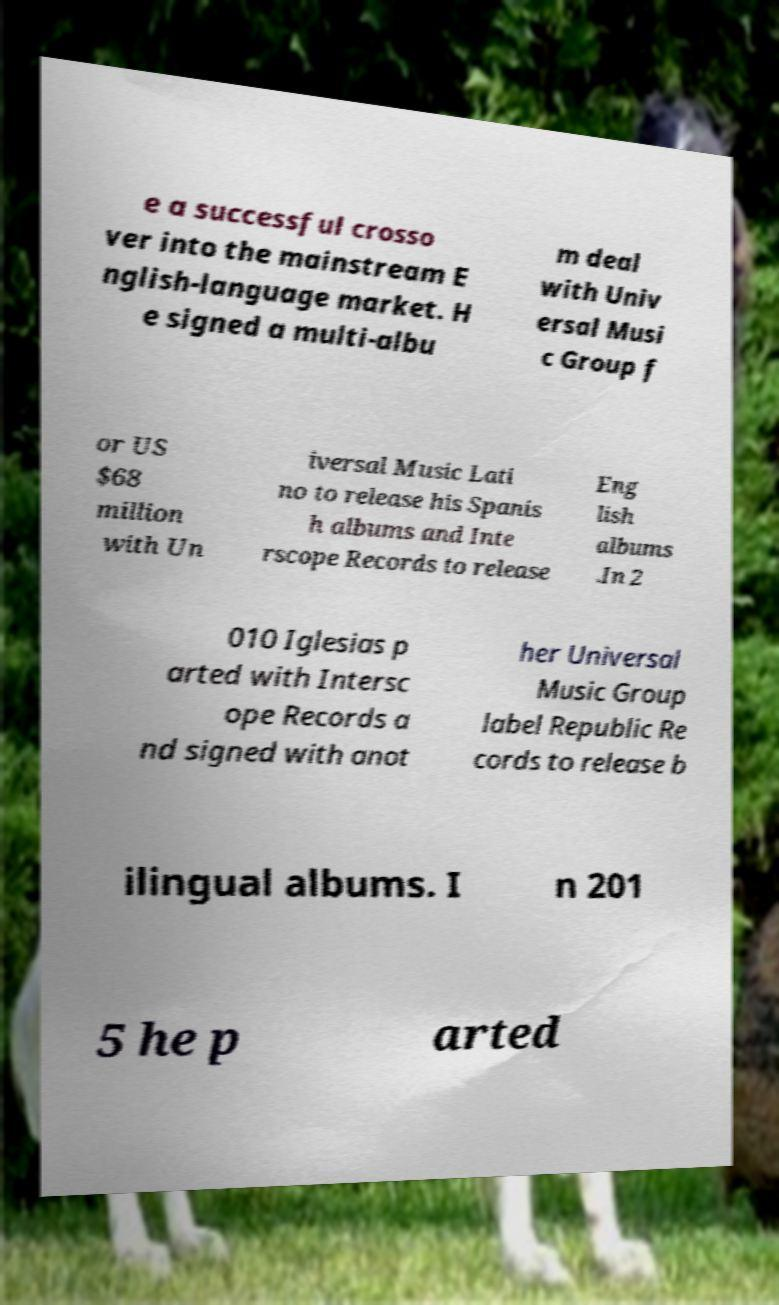What messages or text are displayed in this image? I need them in a readable, typed format. e a successful crosso ver into the mainstream E nglish-language market. H e signed a multi-albu m deal with Univ ersal Musi c Group f or US $68 million with Un iversal Music Lati no to release his Spanis h albums and Inte rscope Records to release Eng lish albums .In 2 010 Iglesias p arted with Intersc ope Records a nd signed with anot her Universal Music Group label Republic Re cords to release b ilingual albums. I n 201 5 he p arted 